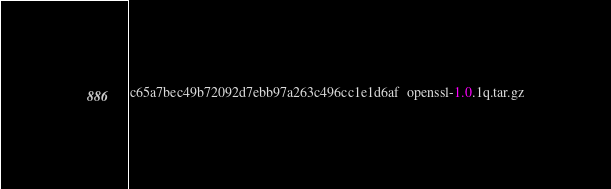<code> <loc_0><loc_0><loc_500><loc_500><_SML_>c65a7bec49b72092d7ebb97a263c496cc1e1d6af  openssl-1.0.1q.tar.gz
</code> 